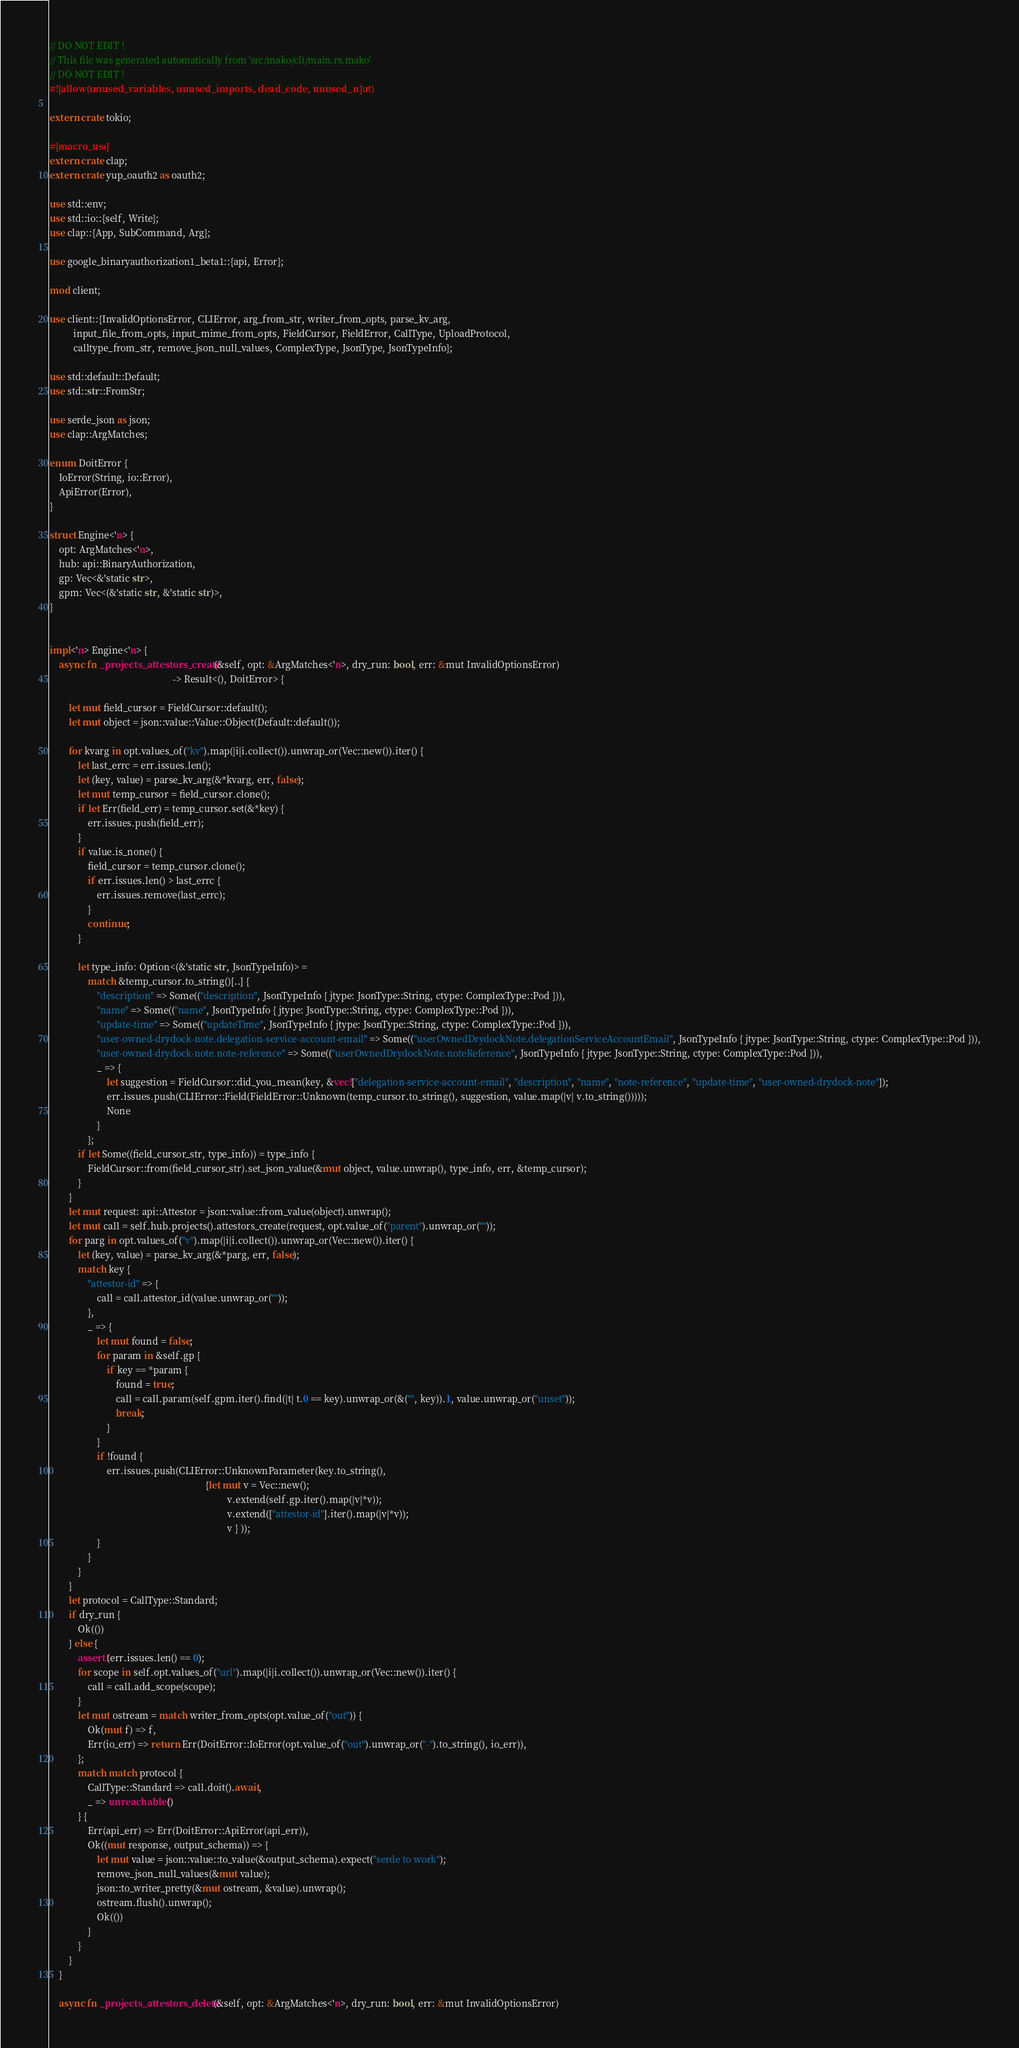Convert code to text. <code><loc_0><loc_0><loc_500><loc_500><_Rust_>// DO NOT EDIT !
// This file was generated automatically from 'src/mako/cli/main.rs.mako'
// DO NOT EDIT !
#![allow(unused_variables, unused_imports, dead_code, unused_mut)]

extern crate tokio;

#[macro_use]
extern crate clap;
extern crate yup_oauth2 as oauth2;

use std::env;
use std::io::{self, Write};
use clap::{App, SubCommand, Arg};

use google_binaryauthorization1_beta1::{api, Error};

mod client;

use client::{InvalidOptionsError, CLIError, arg_from_str, writer_from_opts, parse_kv_arg,
          input_file_from_opts, input_mime_from_opts, FieldCursor, FieldError, CallType, UploadProtocol,
          calltype_from_str, remove_json_null_values, ComplexType, JsonType, JsonTypeInfo};

use std::default::Default;
use std::str::FromStr;

use serde_json as json;
use clap::ArgMatches;

enum DoitError {
    IoError(String, io::Error),
    ApiError(Error),
}

struct Engine<'n> {
    opt: ArgMatches<'n>,
    hub: api::BinaryAuthorization,
    gp: Vec<&'static str>,
    gpm: Vec<(&'static str, &'static str)>,
}


impl<'n> Engine<'n> {
    async fn _projects_attestors_create(&self, opt: &ArgMatches<'n>, dry_run: bool, err: &mut InvalidOptionsError)
                                                    -> Result<(), DoitError> {
        
        let mut field_cursor = FieldCursor::default();
        let mut object = json::value::Value::Object(Default::default());
        
        for kvarg in opt.values_of("kv").map(|i|i.collect()).unwrap_or(Vec::new()).iter() {
            let last_errc = err.issues.len();
            let (key, value) = parse_kv_arg(&*kvarg, err, false);
            let mut temp_cursor = field_cursor.clone();
            if let Err(field_err) = temp_cursor.set(&*key) {
                err.issues.push(field_err);
            }
            if value.is_none() {
                field_cursor = temp_cursor.clone();
                if err.issues.len() > last_errc {
                    err.issues.remove(last_errc);
                }
                continue;
            }
        
            let type_info: Option<(&'static str, JsonTypeInfo)> =
                match &temp_cursor.to_string()[..] {
                    "description" => Some(("description", JsonTypeInfo { jtype: JsonType::String, ctype: ComplexType::Pod })),
                    "name" => Some(("name", JsonTypeInfo { jtype: JsonType::String, ctype: ComplexType::Pod })),
                    "update-time" => Some(("updateTime", JsonTypeInfo { jtype: JsonType::String, ctype: ComplexType::Pod })),
                    "user-owned-drydock-note.delegation-service-account-email" => Some(("userOwnedDrydockNote.delegationServiceAccountEmail", JsonTypeInfo { jtype: JsonType::String, ctype: ComplexType::Pod })),
                    "user-owned-drydock-note.note-reference" => Some(("userOwnedDrydockNote.noteReference", JsonTypeInfo { jtype: JsonType::String, ctype: ComplexType::Pod })),
                    _ => {
                        let suggestion = FieldCursor::did_you_mean(key, &vec!["delegation-service-account-email", "description", "name", "note-reference", "update-time", "user-owned-drydock-note"]);
                        err.issues.push(CLIError::Field(FieldError::Unknown(temp_cursor.to_string(), suggestion, value.map(|v| v.to_string()))));
                        None
                    }
                };
            if let Some((field_cursor_str, type_info)) = type_info {
                FieldCursor::from(field_cursor_str).set_json_value(&mut object, value.unwrap(), type_info, err, &temp_cursor);
            }
        }
        let mut request: api::Attestor = json::value::from_value(object).unwrap();
        let mut call = self.hub.projects().attestors_create(request, opt.value_of("parent").unwrap_or(""));
        for parg in opt.values_of("v").map(|i|i.collect()).unwrap_or(Vec::new()).iter() {
            let (key, value) = parse_kv_arg(&*parg, err, false);
            match key {
                "attestor-id" => {
                    call = call.attestor_id(value.unwrap_or(""));
                },
                _ => {
                    let mut found = false;
                    for param in &self.gp {
                        if key == *param {
                            found = true;
                            call = call.param(self.gpm.iter().find(|t| t.0 == key).unwrap_or(&("", key)).1, value.unwrap_or("unset"));
                            break;
                        }
                    }
                    if !found {
                        err.issues.push(CLIError::UnknownParameter(key.to_string(),
                                                                  {let mut v = Vec::new();
                                                                           v.extend(self.gp.iter().map(|v|*v));
                                                                           v.extend(["attestor-id"].iter().map(|v|*v));
                                                                           v } ));
                    }
                }
            }
        }
        let protocol = CallType::Standard;
        if dry_run {
            Ok(())
        } else {
            assert!(err.issues.len() == 0);
            for scope in self.opt.values_of("url").map(|i|i.collect()).unwrap_or(Vec::new()).iter() {
                call = call.add_scope(scope);
            }
            let mut ostream = match writer_from_opts(opt.value_of("out")) {
                Ok(mut f) => f,
                Err(io_err) => return Err(DoitError::IoError(opt.value_of("out").unwrap_or("-").to_string(), io_err)),
            };
            match match protocol {
                CallType::Standard => call.doit().await,
                _ => unreachable!()
            } {
                Err(api_err) => Err(DoitError::ApiError(api_err)),
                Ok((mut response, output_schema)) => {
                    let mut value = json::value::to_value(&output_schema).expect("serde to work");
                    remove_json_null_values(&mut value);
                    json::to_writer_pretty(&mut ostream, &value).unwrap();
                    ostream.flush().unwrap();
                    Ok(())
                }
            }
        }
    }

    async fn _projects_attestors_delete(&self, opt: &ArgMatches<'n>, dry_run: bool, err: &mut InvalidOptionsError)</code> 